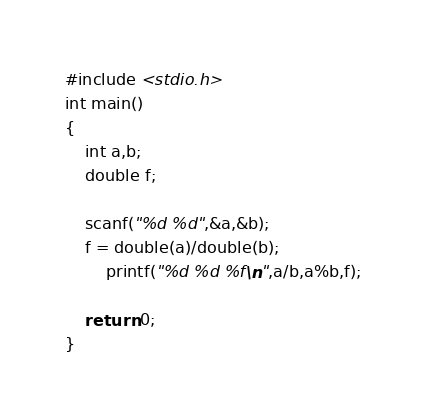Convert code to text. <code><loc_0><loc_0><loc_500><loc_500><_C_>#include <stdio.h>
int main()
{
	int a,b;
	double f;

	scanf("%d %d",&a,&b);
	f = double(a)/double(b);
		printf("%d %d %f\n",a/b,a%b,f);

	return 0;
}</code> 